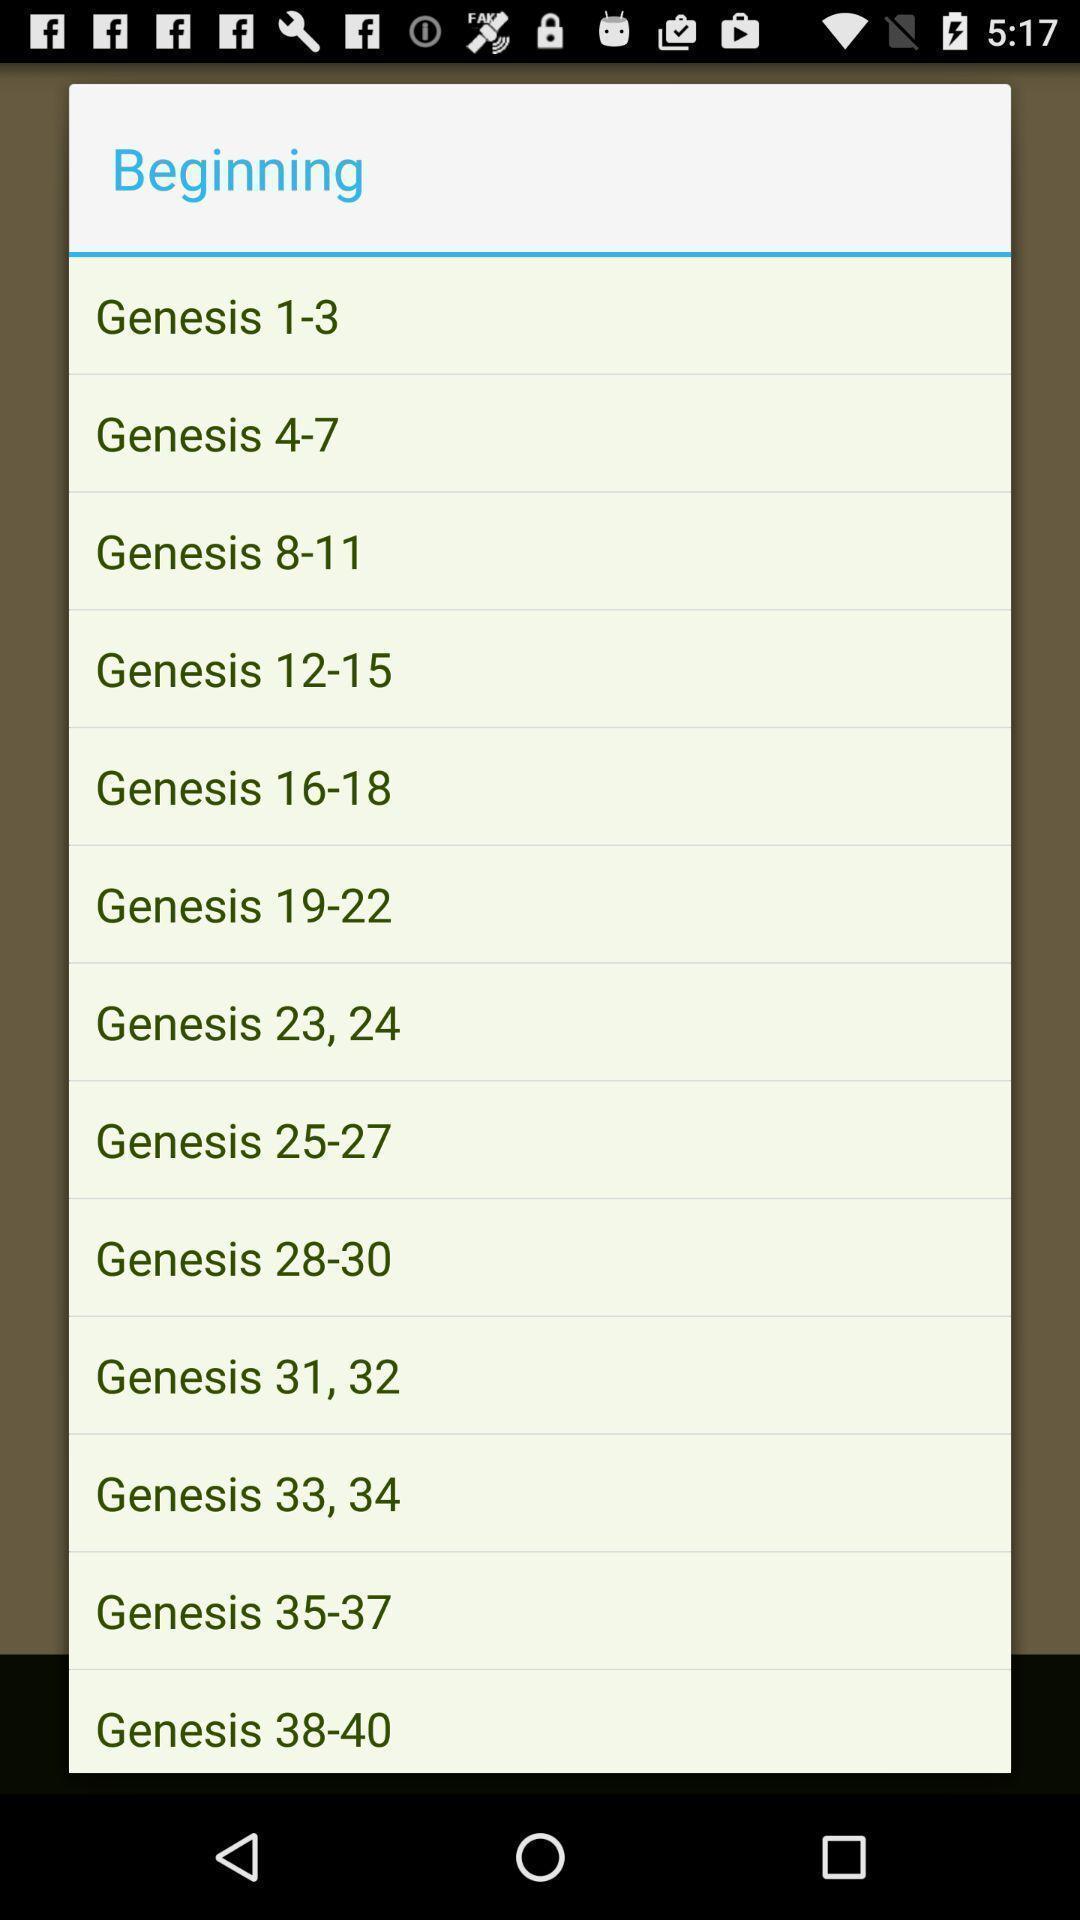Please provide a description for this image. Screen shows about religious scripture. 